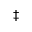Convert formula to latex. <formula><loc_0><loc_0><loc_500><loc_500>\ddagger</formula> 